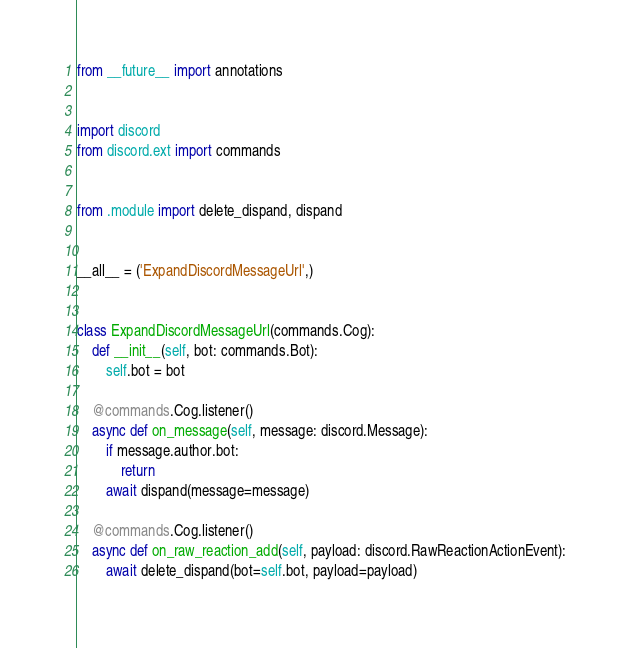<code> <loc_0><loc_0><loc_500><loc_500><_Python_>from __future__ import annotations


import discord
from discord.ext import commands


from .module import delete_dispand, dispand


__all__ = ('ExpandDiscordMessageUrl',)


class ExpandDiscordMessageUrl(commands.Cog):
    def __init__(self, bot: commands.Bot):
        self.bot = bot

    @commands.Cog.listener()
    async def on_message(self, message: discord.Message):
        if message.author.bot:
            return
        await dispand(message=message)

    @commands.Cog.listener()
    async def on_raw_reaction_add(self, payload: discord.RawReactionActionEvent):
        await delete_dispand(bot=self.bot, payload=payload)
</code> 